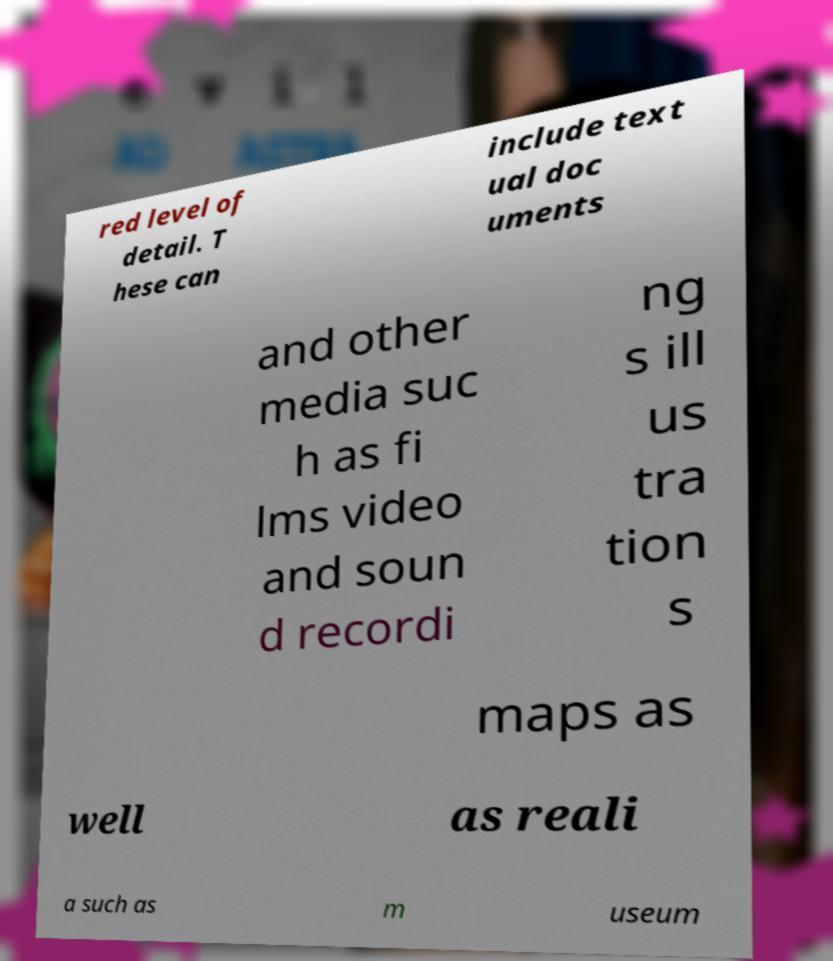Please read and relay the text visible in this image. What does it say? red level of detail. T hese can include text ual doc uments and other media suc h as fi lms video and soun d recordi ng s ill us tra tion s maps as well as reali a such as m useum 